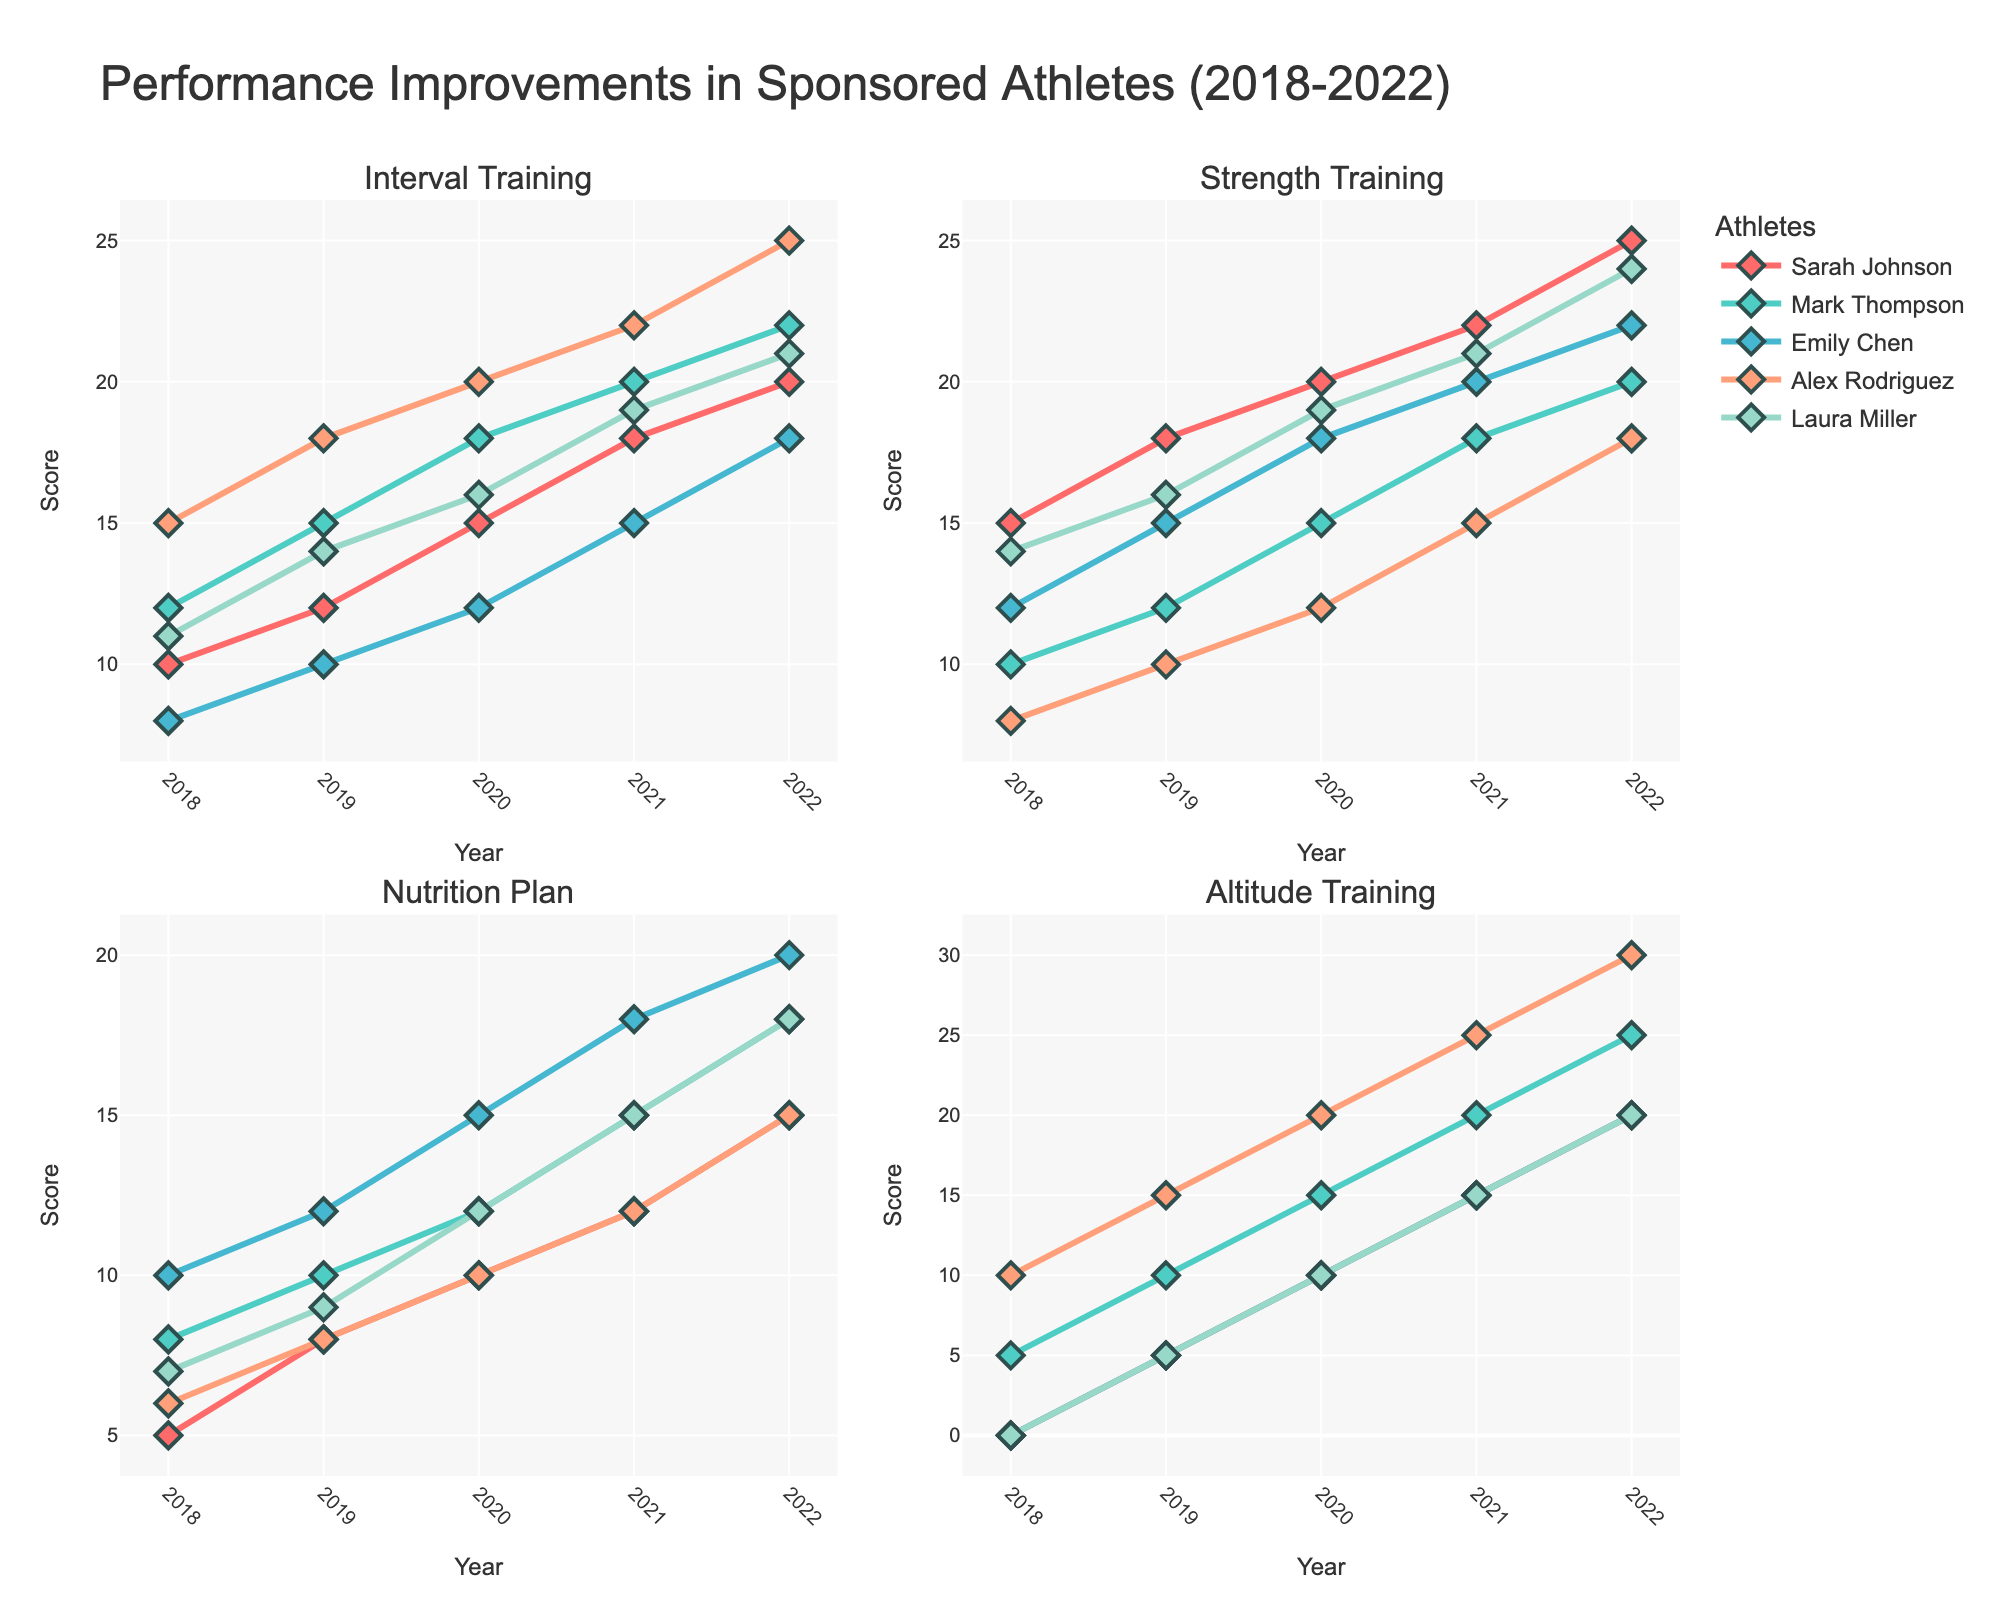How many subplots are there in the figure? The figure contains a total of 4 subplots as indicated by the subplot titles.
Answer: 4 What is the title of the plot? The title of the plot is displayed at the top, which is "Performance Improvements in Sponsored Athletes (2018-2022)".
Answer: Performance Improvements in Sponsored Athletes (2018-2022) Which training type shows the most significant improvement for Alex Rodriguez over the years? By looking at the line for Alex Rodriguez in all subplots, it’s evident that the "Altitude Training" subplot (bottom right) shows the most dramatic increase for Alex, starting from 10 in 2018 to 30 in 2022.
Answer: Altitude Training Who has the highest score in Interval Training in 2022? On the Interval Training subplot (top left), Mark Thompson has the highest score represented by the highest point on the plot for the year 2022, which reaches 22.
Answer: Mark Thompson What is the average Strength Training score for Laura Miller over the 5 years? Laura Miller's Strength Training scores over the years are 14, 16, 19, 21, and 24. The average is calculated as (14 + 16 + 19 + 21 + 24) / 5 = 18.8.
Answer: 18.8 Between Mark Thompson and Sarah Johnson, who saw a greater improvement in their Nutrition Plan scores from 2018 to 2022? Sarah Johnson’s scores went from 5 in 2018 to 15 in 2022, an improvement of 15 - 5 = 10. Mark Thompson’s scores went from 8 in 2018 to 18 in 2022, an improvement of 18 - 8 = 10. Therefore, both athletes had the same improvement.
Answer: Both had the same improvement Which athlete has the most consistent performance in terms of Endurance Improvement? Assess the Endurance Improvement subplot (not directly given but inferrable through the title) and identify the line that fluctuates the least. Emily Chen’s line appears the most consistent, with a steady and smaller range of values (7, 10, 14, 18, 22).
Answer: Emily Chen How much did Sarah Johnson’s Interval Training score increase from 2018 to 2022? Sarah Johnson’s scores in Interval Training went from 10 in 2018 to 20 in 2022, an increase of 20 - 10 = 10 points.
Answer: 10 points How does the Endurance Improvement of Mark Thompson in 2021 compare to his Endurance Improvement in 2018? Mark Thompson's Endurance Improvement in 2018 was 10, and in 2021 it was 22. Comparing the two, 22 is greater than 10.
Answer: It is greater 